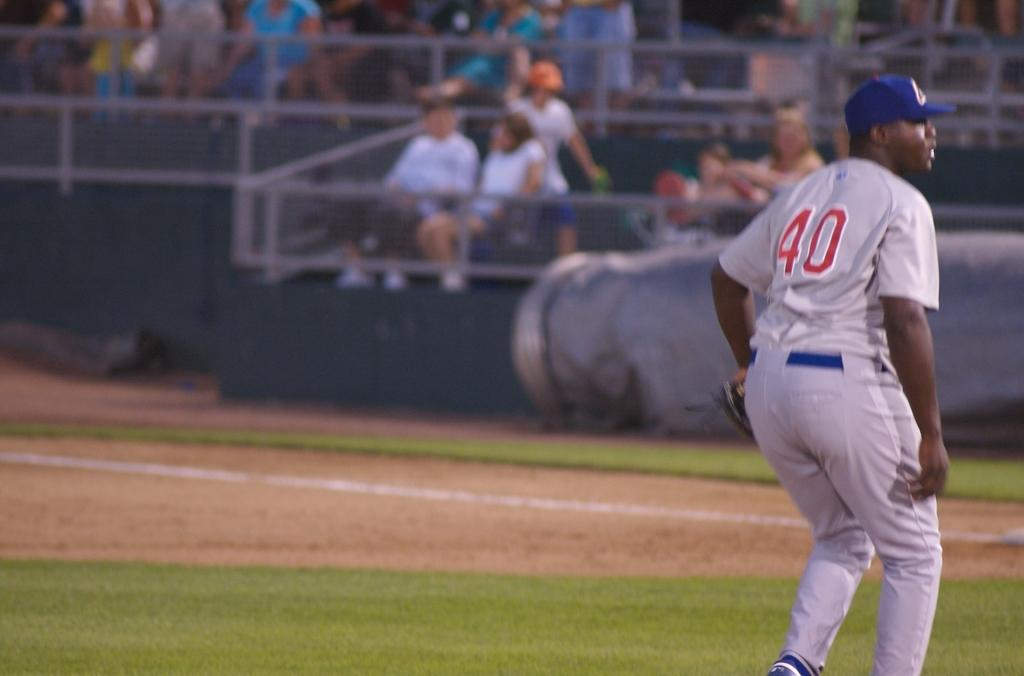<image>
Render a clear and concise summary of the photo. a baseball player in a grey uniform with the number 40 on it 